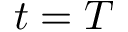Convert formula to latex. <formula><loc_0><loc_0><loc_500><loc_500>t = T</formula> 